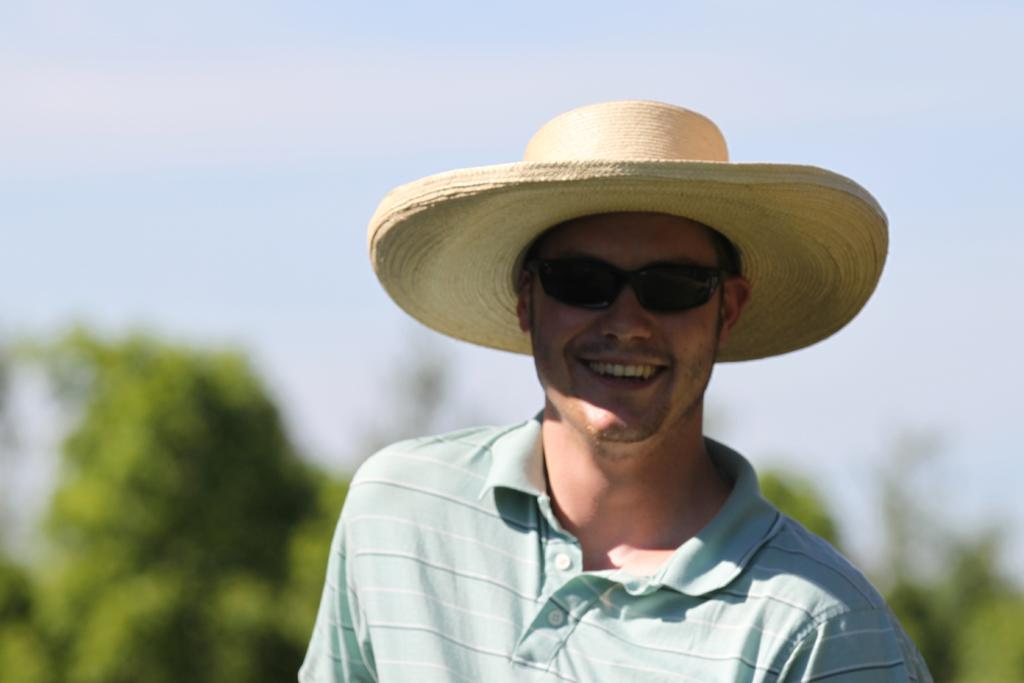Who or what is present in the image? There is a person in the image. What accessories is the person wearing? The person is wearing a hat and glasses. What can be seen in the background of the image? There are plants and the sky visible in the image. How many weeks has the person been attending the church in the image? There is no church present in the image, and therefore no information about the person's attendance. 